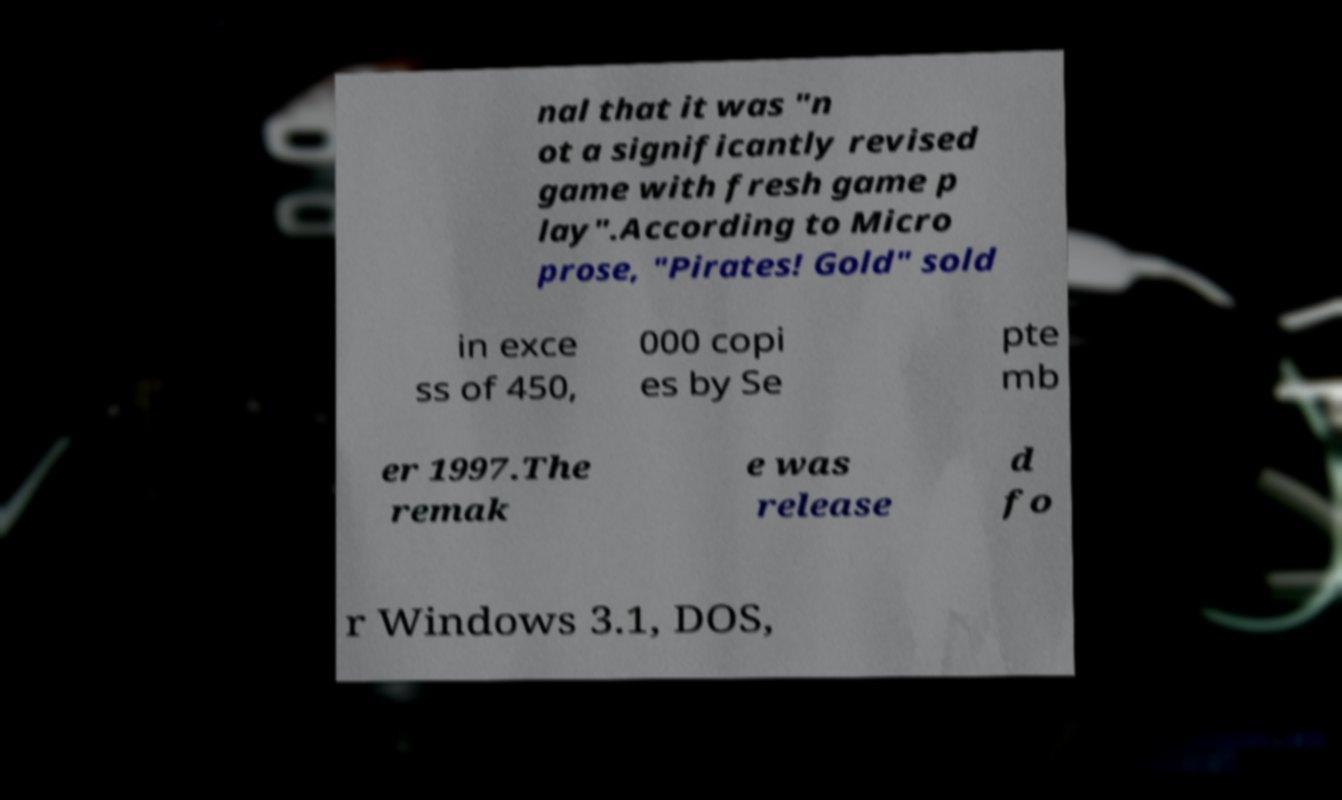I need the written content from this picture converted into text. Can you do that? nal that it was "n ot a significantly revised game with fresh game p lay".According to Micro prose, "Pirates! Gold" sold in exce ss of 450, 000 copi es by Se pte mb er 1997.The remak e was release d fo r Windows 3.1, DOS, 